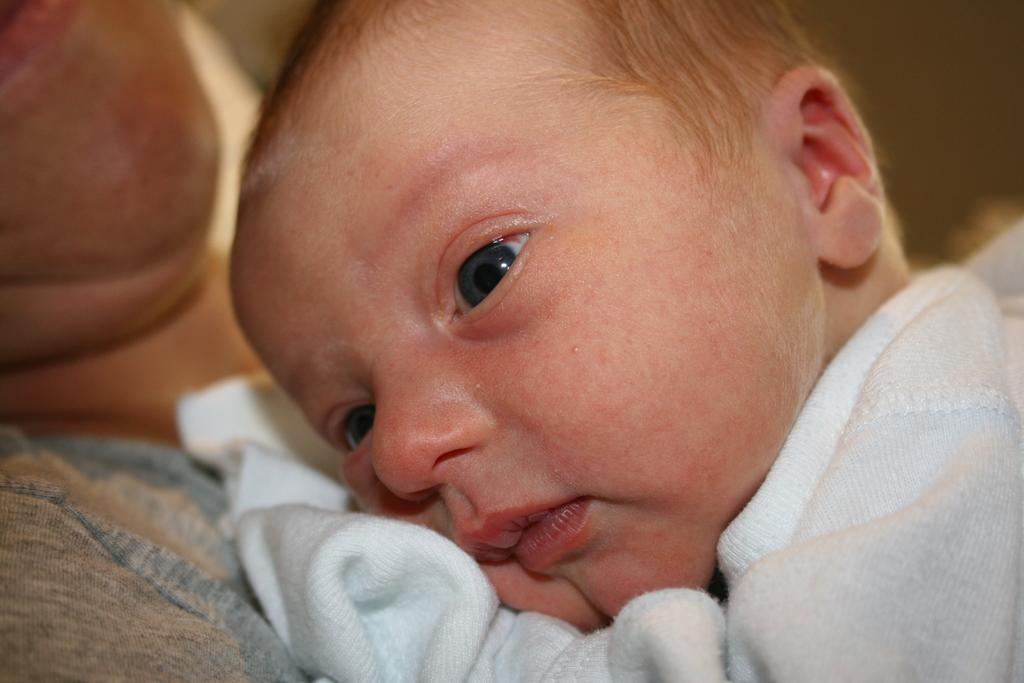What is the main subject of the image? There is a baby in the image. What is the baby's position in the image? The baby is lying on a person. Can you describe the background of the image? The background of the image is blurry. How many tickets can be seen in the image? There are no tickets present in the image. What type of furniture is visible in the image? There is no furniture visible in the image. 